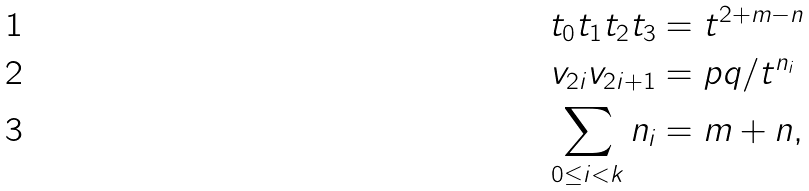<formula> <loc_0><loc_0><loc_500><loc_500>t _ { 0 } t _ { 1 } t _ { 2 } t _ { 3 } & = t ^ { 2 + m - n } \\ v _ { 2 i } v _ { 2 i + 1 } & = p q / t ^ { n _ { i } } \\ \sum _ { 0 \leq i < k } n _ { i } & = m + n ,</formula> 